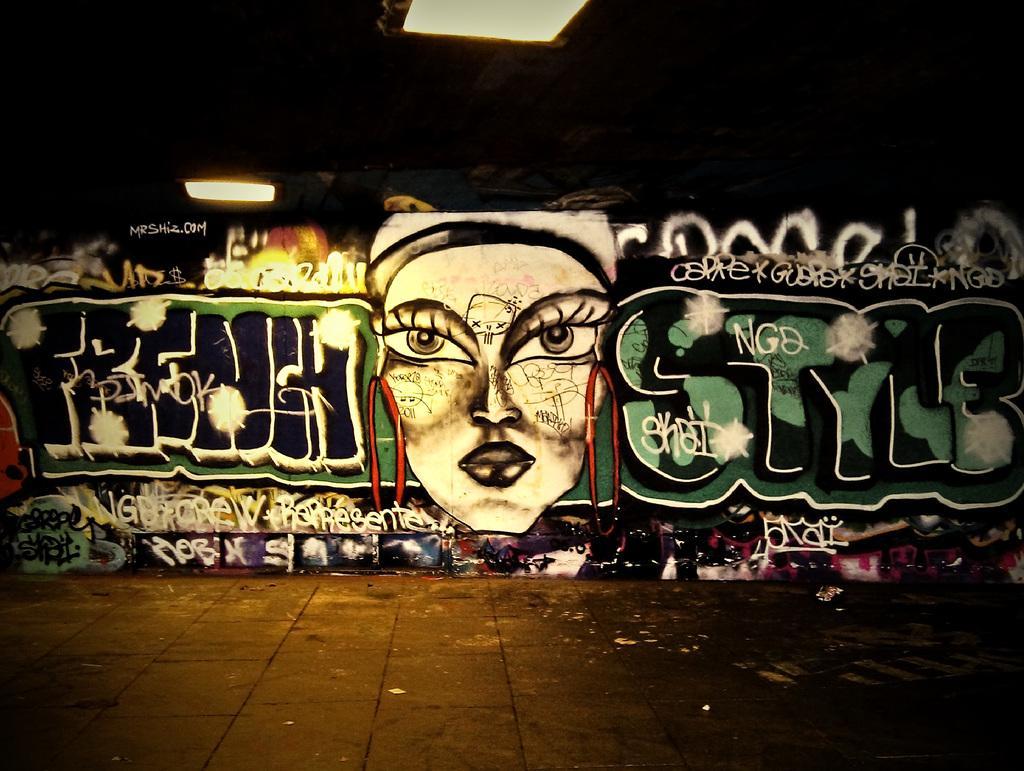Can you describe this image briefly? In this image we can see the road, graffiti on the wall, ceiling lights and this part of the image is dark. 